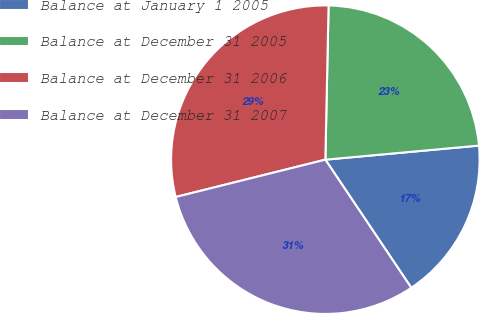<chart> <loc_0><loc_0><loc_500><loc_500><pie_chart><fcel>Balance at January 1 2005<fcel>Balance at December 31 2005<fcel>Balance at December 31 2006<fcel>Balance at December 31 2007<nl><fcel>17.05%<fcel>23.21%<fcel>29.22%<fcel>30.51%<nl></chart> 